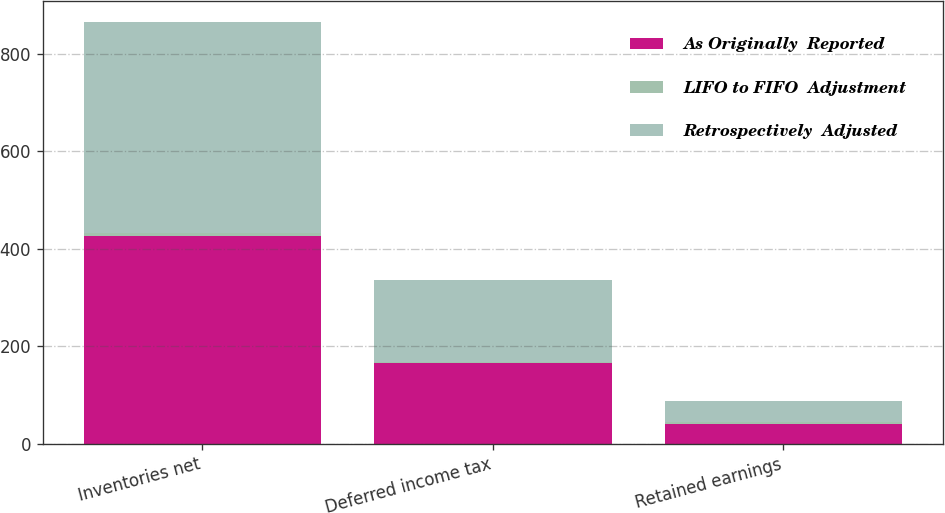<chart> <loc_0><loc_0><loc_500><loc_500><stacked_bar_chart><ecel><fcel>Inventories net<fcel>Deferred income tax<fcel>Retained earnings<nl><fcel>As Originally  Reported<fcel>426<fcel>165<fcel>40<nl><fcel>LIFO to FIFO  Adjustment<fcel>7<fcel>3<fcel>4<nl><fcel>Retrospectively  Adjusted<fcel>433<fcel>168<fcel>44<nl></chart> 